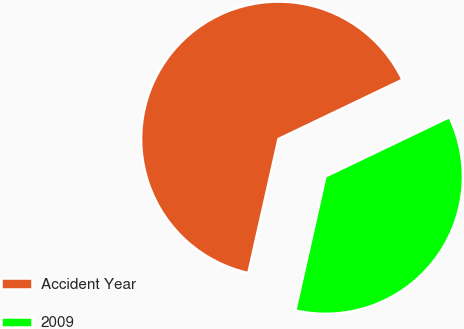Convert chart. <chart><loc_0><loc_0><loc_500><loc_500><pie_chart><fcel>Accident Year<fcel>2009<nl><fcel>64.37%<fcel>35.63%<nl></chart> 